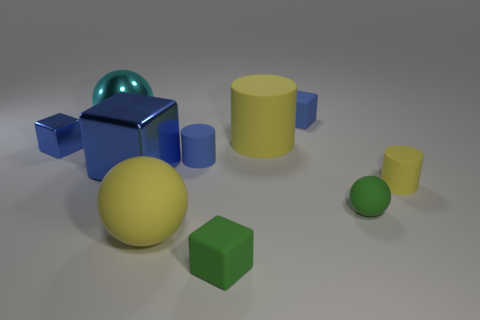Is the color of the big cylinder the same as the big rubber thing in front of the large shiny block?
Offer a very short reply. Yes. Is there any other thing that is the same color as the tiny sphere?
Offer a terse response. Yes. How many green cubes are the same size as the green sphere?
Offer a very short reply. 1. The small thing that is the same color as the big cylinder is what shape?
Make the answer very short. Cylinder. The large metal thing that is in front of the big ball on the left side of the big yellow matte ball to the left of the tiny sphere is what shape?
Give a very brief answer. Cube. The large metal thing that is to the right of the cyan metallic object is what color?
Provide a succinct answer. Blue. How many objects are either tiny things that are on the right side of the small shiny object or large things to the right of the big cyan metallic sphere?
Your response must be concise. 8. How many other cyan objects have the same shape as the large cyan shiny thing?
Provide a short and direct response. 0. The matte cylinder that is the same size as the cyan sphere is what color?
Ensure brevity in your answer.  Yellow. The rubber block in front of the tiny block behind the tiny blue thing that is to the left of the large shiny ball is what color?
Provide a succinct answer. Green. 